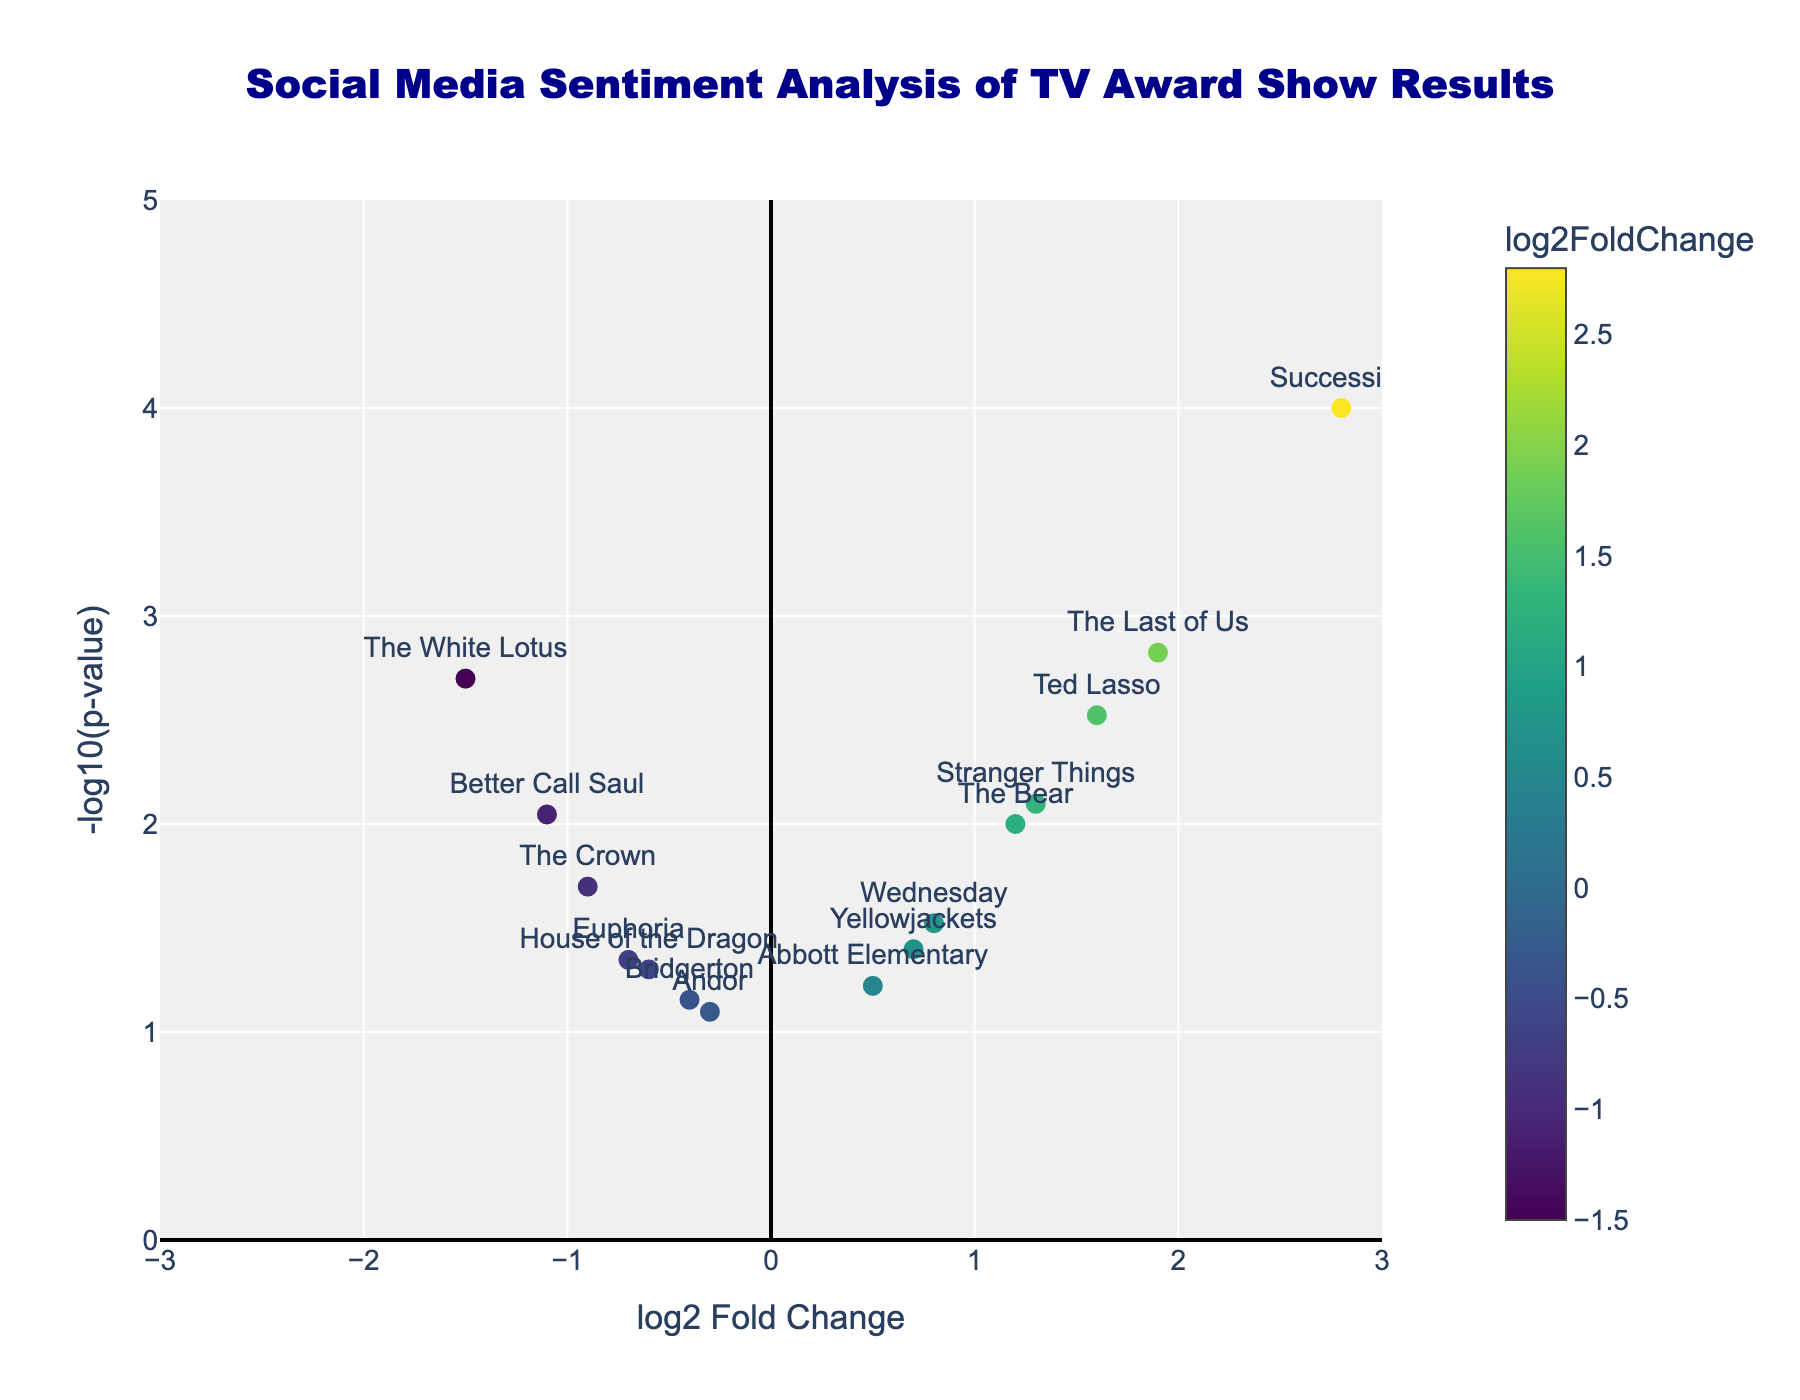How many data points are represented in the plot? By counting the markers (points) displayed in the scatter plot, each point represents a TV show. We can count them to determine the total number of data points. There are 15 TV shows, so there are 15 data points.
Answer: 15 Which TV show had the most positive sentiment change after the award show? We need to look at the TV show with the highest log2FoldChange value (rightmost point on the x-axis). "Succession" has the highest positive log2FoldChange value of 2.8.
Answer: Succession What does a -log10(p-value) of 3 indicate in terms of p-value? Knowing the inverse relationship between p-values and -log10(p-values): -log10(0.001) = 3. Hence, a -log10(p-value) of 3 indicates a p-value of 0.001.
Answer: 0.001 Which TV show had a significant negative sentiment change with a p-value less than 0.01? We need to find a TV show with negative log2FoldChange (left side of the plot) and a high -log10(p-value). "The White Lotus" meets these criteria with a log2FoldChange of -1.5 and a p-value of 0.002.
Answer: The White Lotus What is the color scale used in the plot to represent TV shows? Observing the colors of the data points, we notice that the color scale varies based on the log2FoldChange values. Positive values may be shown in warm colors and negative values in cool colors. The colors are mapped using the Viridis color scale.
Answer: Viridis Are there any shows with a p-value very close to the significance threshold of 0.05? We need to look for points with a -log10(p-value) value close to -log10(0.05), which is approximately 1.3 on the y-axis. "House of the Dragon" and "Euphoria" have p-values of 0.05 and 0.045, respectively, near the significance threshold.
Answer: House of the Dragon, Euphoria Which TV show had the least significant p-value and what was its sentiment change? Find the point with the lowest -log10(p-value) on the y-axis. "Andor" has the least significant p-value of 0.08, with a log2FoldChange of -0.3.
Answer: Andor, -0.3 Among the shows "The Crown" and "Ted Lasso," which had a higher absolute sentiment change? Compare their absolute log2FoldChange values: "The Crown" (-0.9) and "Ted Lasso" (1.6). "Ted Lasso" has a higher value when ignoring the sign.
Answer: Ted Lasso Which TV shows have a log2FoldChange greater than 1 but less than 2 with a p-value below 0.01? We need to filter for shows with log2FoldChange between 1 and 2 and -log10(p-value) above 2. These shows are "The Last of Us" and "Ted Lasso," with respective log2FoldChange values of 1.9 and 1.6.
Answer: The Last of Us, Ted Lasso What is the range of -log10(p-value) for the TV shows? The range is calculated by subtracting the minimum -log10(p-value) from the maximum value. The minimum is close to 1.09 (corresponding to a p-value of 0.08 for "Andor"), and the maximum is 4 (for "Succession"). Therefore, the range is approximately 4 - 1.09 = 2.91.
Answer: 2.91 